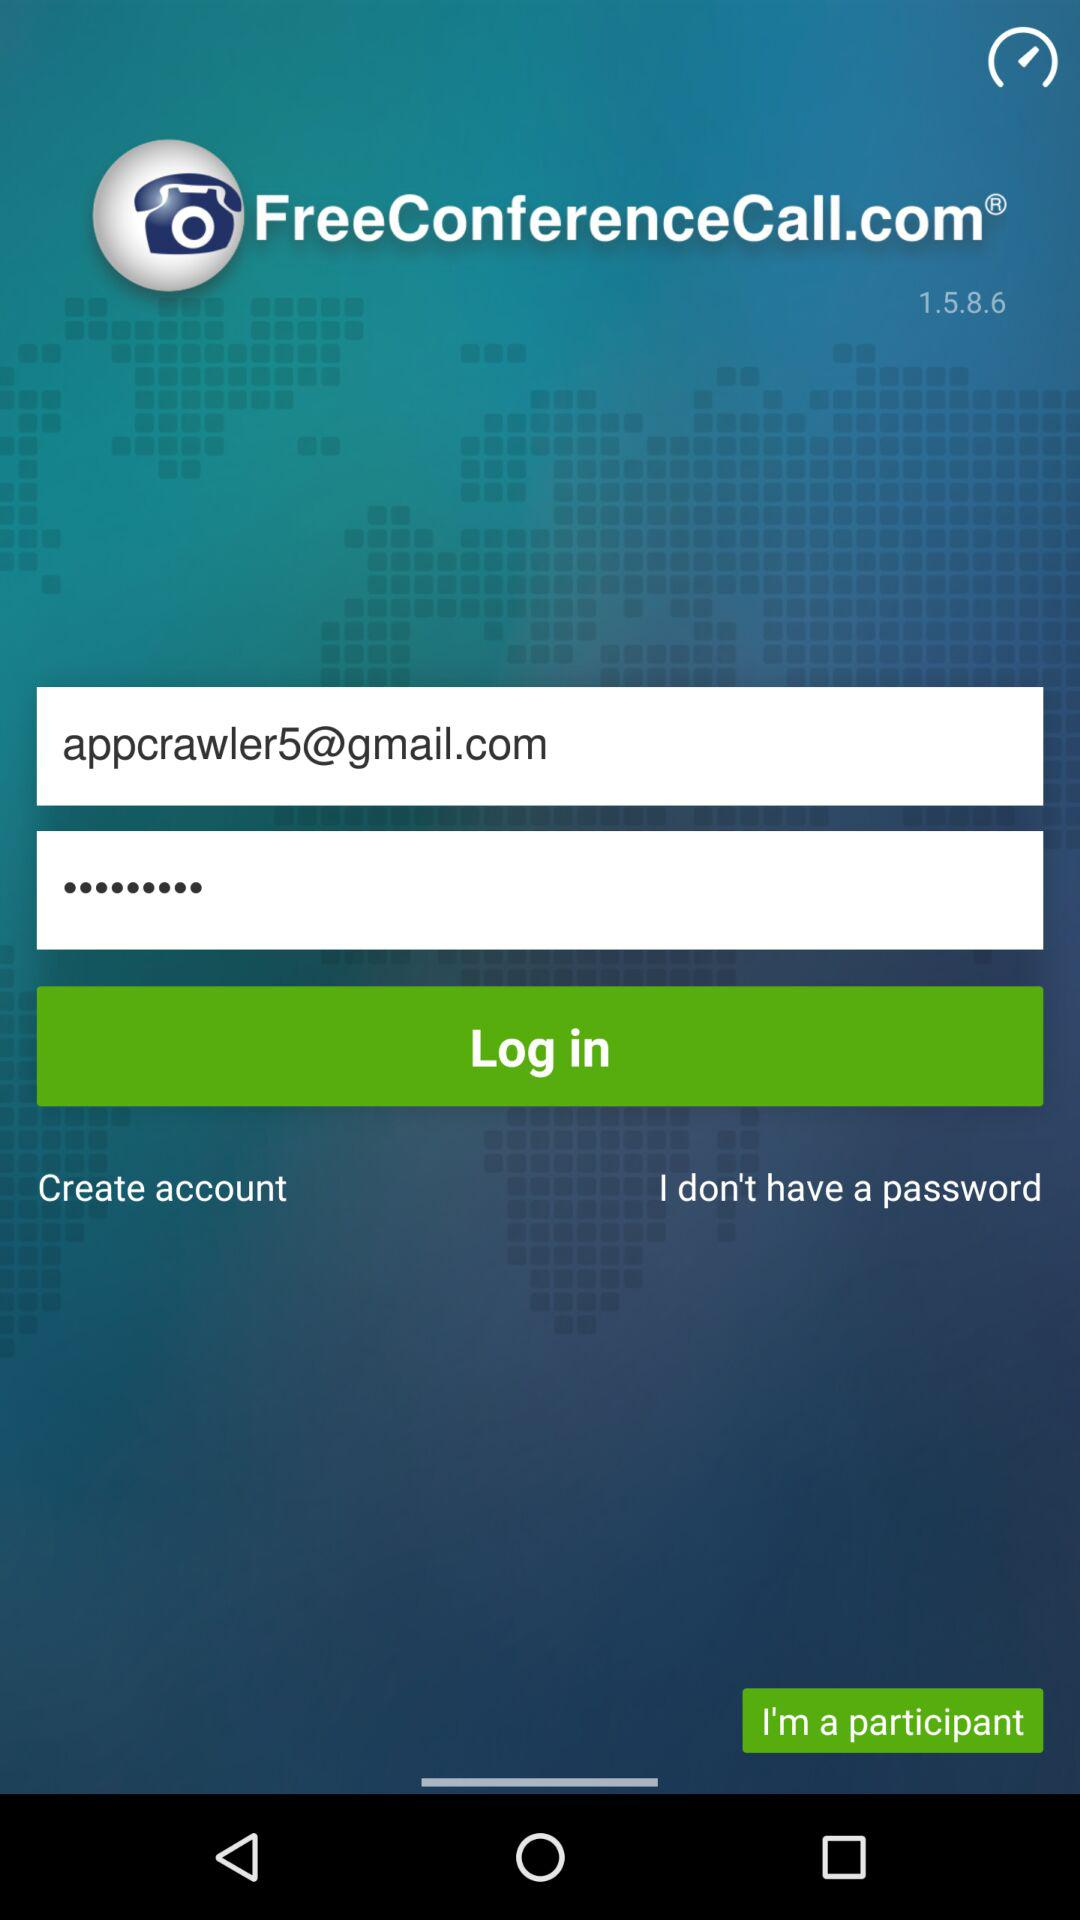What is the email address? The email address is appcrawler5@gmail.com. 